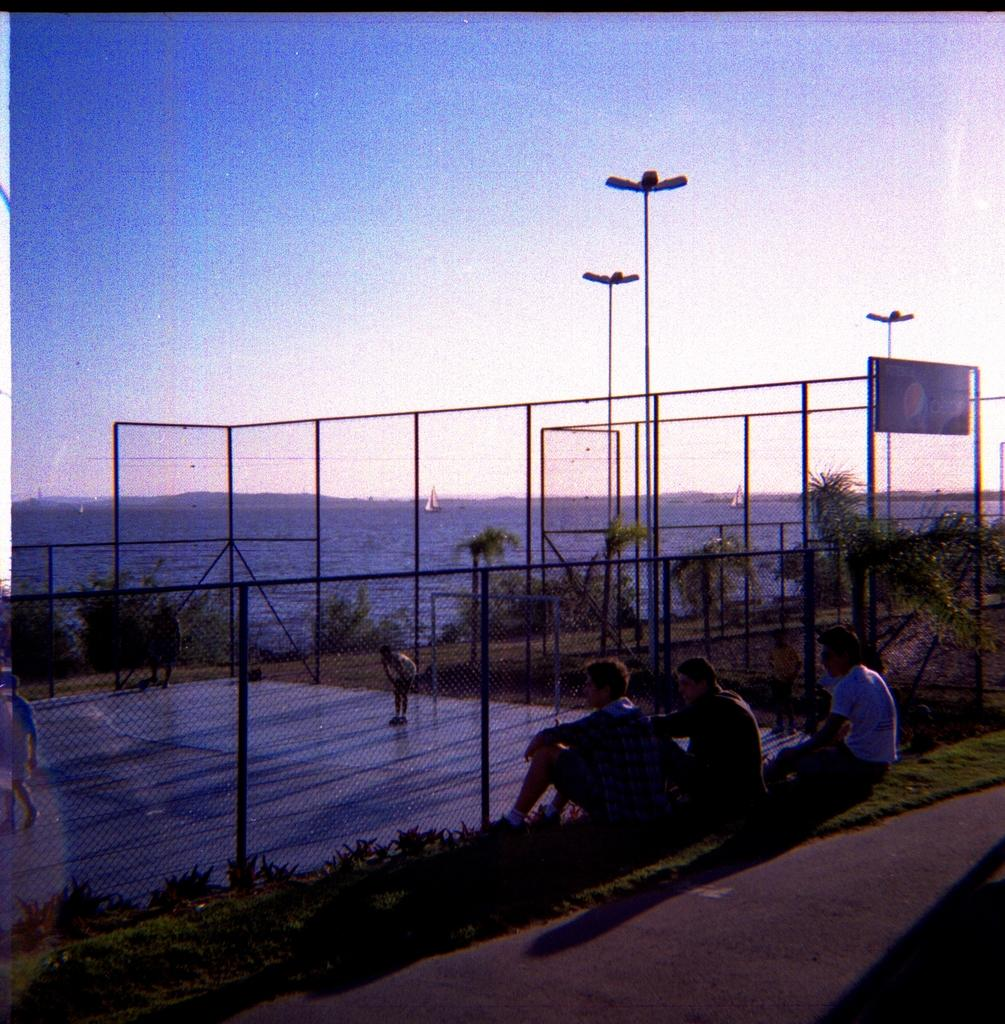What are the people in the image doing? The people in the image are seated on the grass. What type of lighting is present in the image? There are pole lights in the image. What can be seen on the water in the image? There are boats on the water. How would you describe the sky in the image? The sky is cloudy in the image. What type of vegetation is present in the image? There are trees in the image. What type of barrier surrounds the area in the image? There is a metal fence around the area. What flavor of cream is being used to paint the trees in the image? There is no cream or painting activity present in the image; the trees are natural vegetation. What month is it in the image? The image does not provide any information about the month or time of year. 